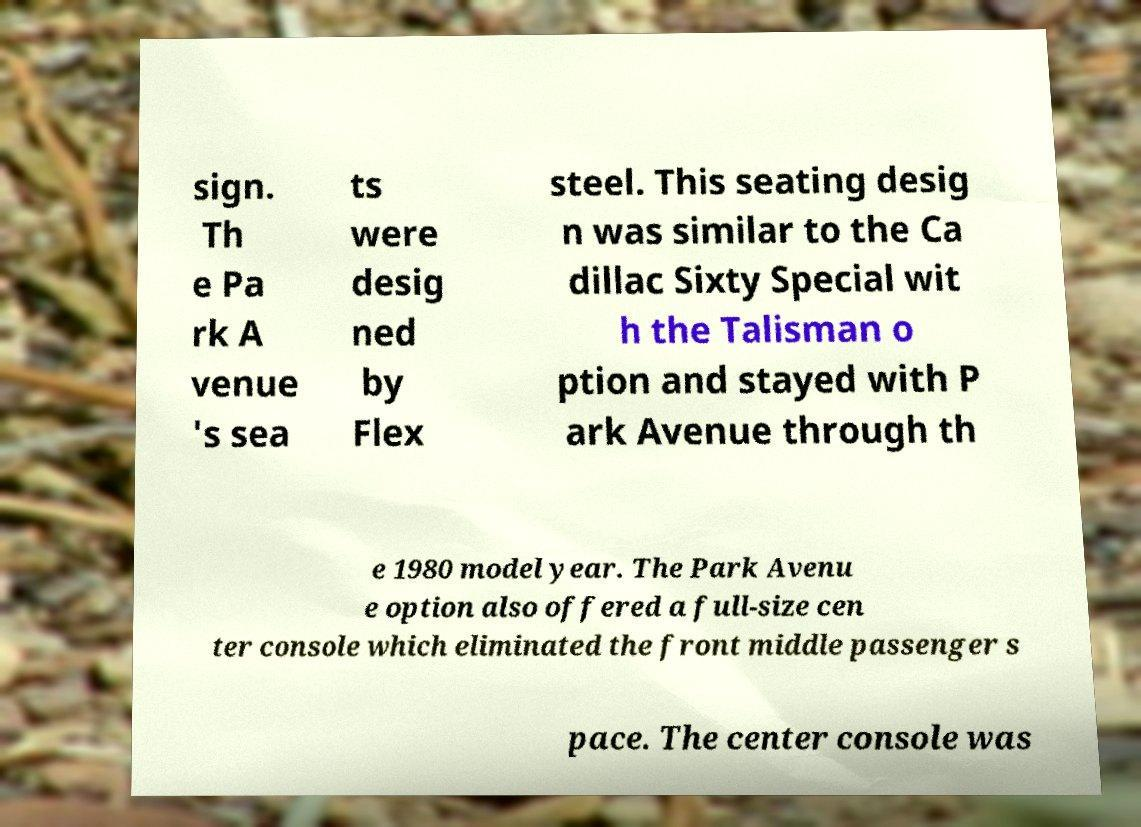Can you accurately transcribe the text from the provided image for me? sign. Th e Pa rk A venue 's sea ts were desig ned by Flex steel. This seating desig n was similar to the Ca dillac Sixty Special wit h the Talisman o ption and stayed with P ark Avenue through th e 1980 model year. The Park Avenu e option also offered a full-size cen ter console which eliminated the front middle passenger s pace. The center console was 